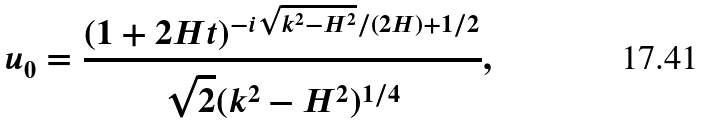Convert formula to latex. <formula><loc_0><loc_0><loc_500><loc_500>u _ { 0 } = \frac { ( 1 + 2 H t ) ^ { - { i } \sqrt { k ^ { 2 } - H ^ { 2 } } / ( 2 H ) + { 1 } / { 2 } } } { \sqrt { 2 } ( k ^ { 2 } - H ^ { 2 } ) ^ { 1 / 4 } } ,</formula> 